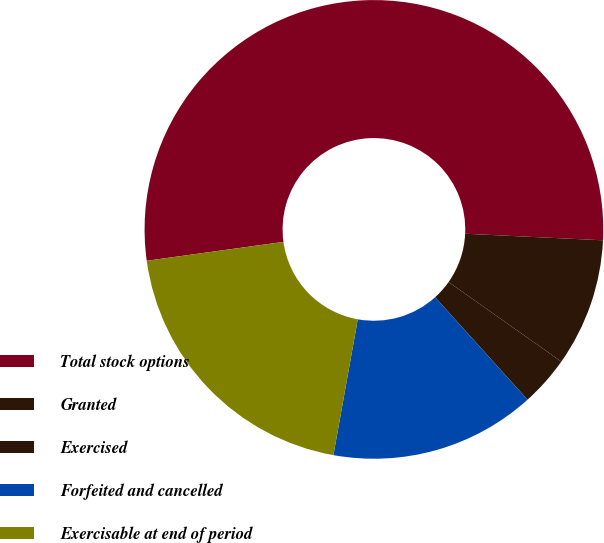Convert chart to OTSL. <chart><loc_0><loc_0><loc_500><loc_500><pie_chart><fcel>Total stock options<fcel>Granted<fcel>Exercised<fcel>Forfeited and cancelled<fcel>Exercisable at end of period<nl><fcel>52.94%<fcel>9.02%<fcel>3.54%<fcel>14.51%<fcel>19.99%<nl></chart> 